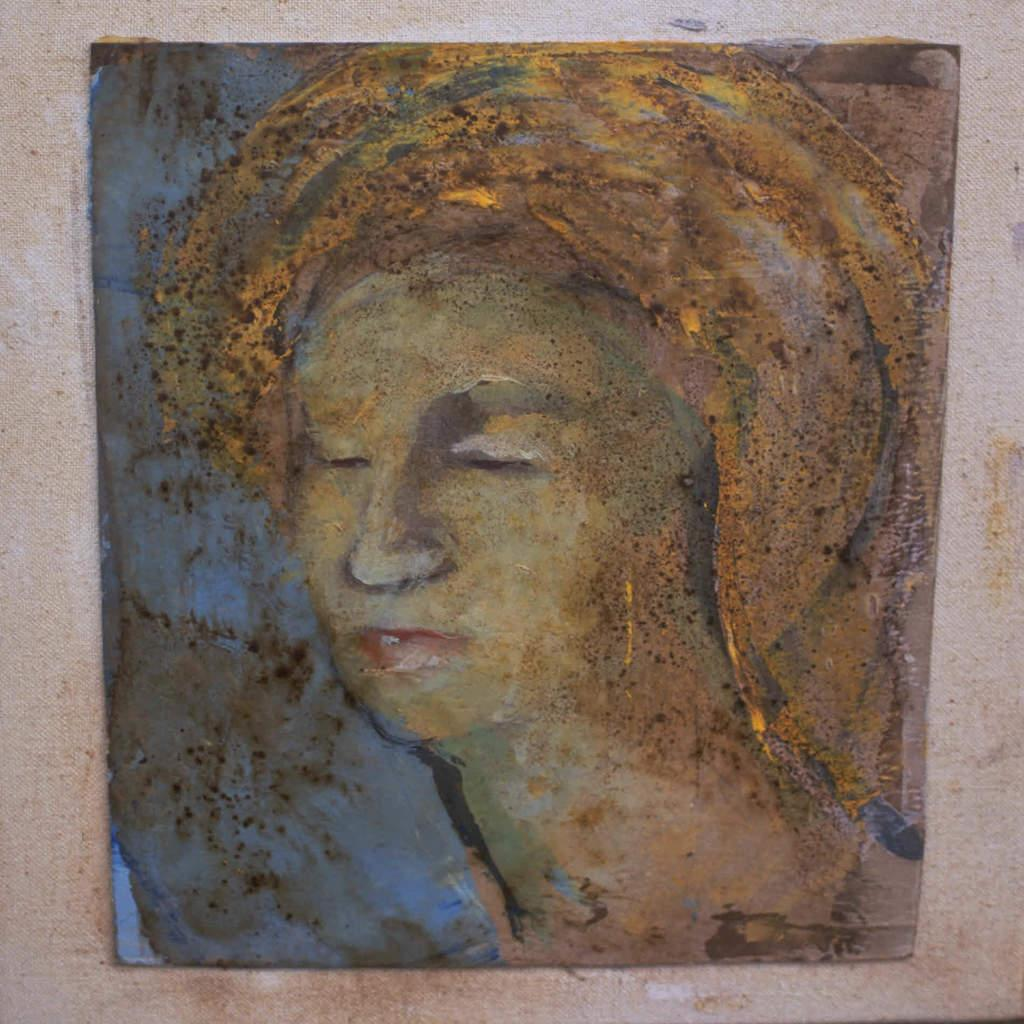What object can be seen in the image that is typically used for displaying photos? There is a photo frame in the image. Where is the photo frame located? The photo frame is on a wall. What type of car is parked next to the photo frame in the image? There is no car present in the image; it only features a photo frame on a wall. 